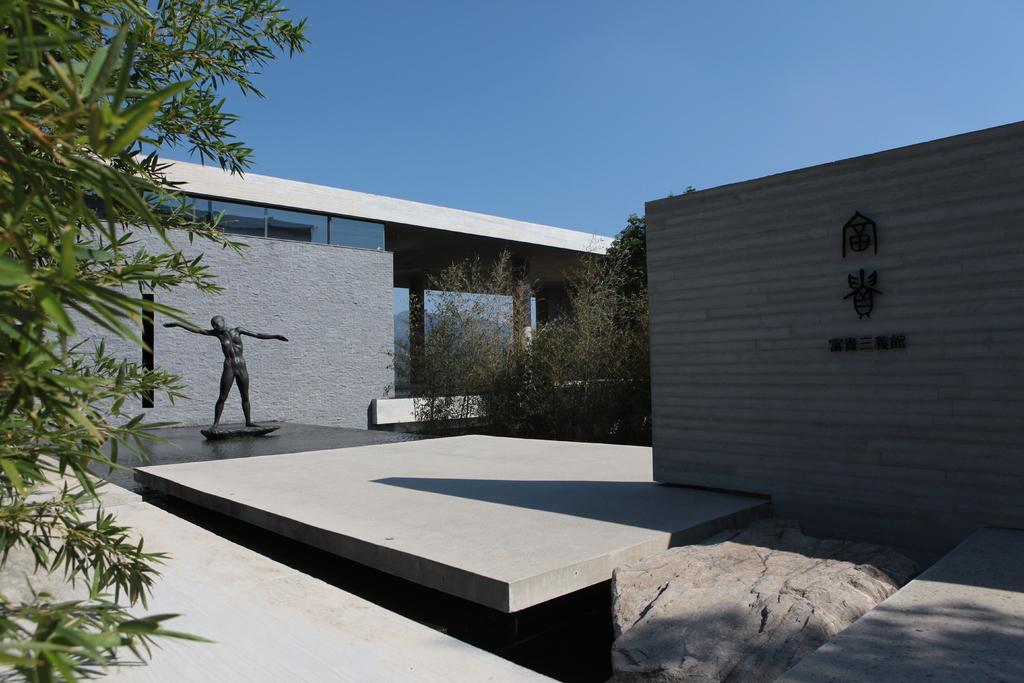Can you describe this image briefly? This is an outside view. On the right side there is a wall on which I can see some text. On the left side few leaves are visible. At the bottom, I can see the floor. In the bottom right there is a rock. On the left side there is a statue of a person. In the background there is a building and some trees. At the top of the image I can see the sky. 